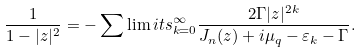<formula> <loc_0><loc_0><loc_500><loc_500>\frac { 1 } { 1 - | z | ^ { 2 } } = - \sum \lim i t s _ { k = 0 } ^ { \infty } \frac { 2 \Gamma | z | ^ { 2 k } } { J _ { n } ( z ) + i \mu _ { q } - \varepsilon _ { k } - \Gamma } .</formula> 